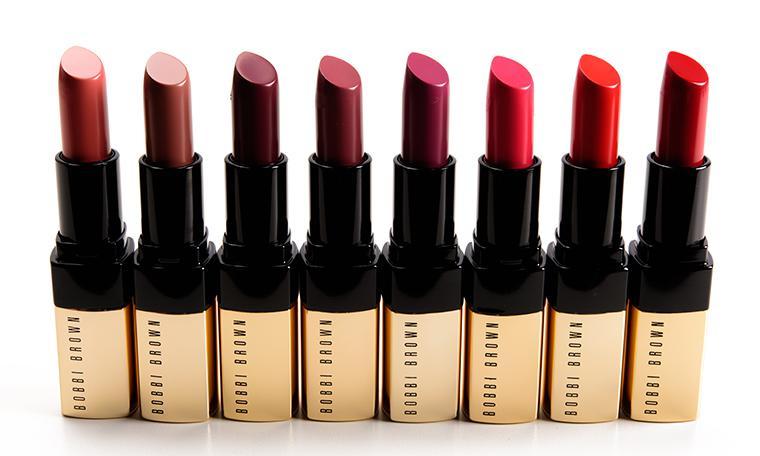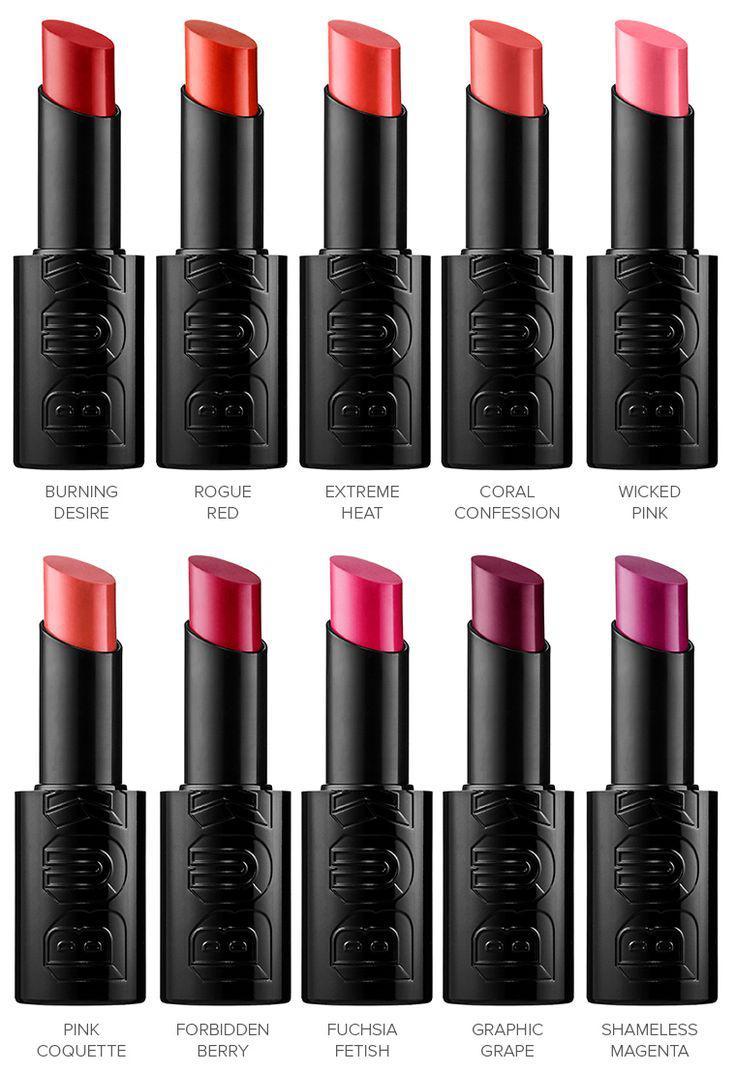The first image is the image on the left, the second image is the image on the right. For the images shown, is this caption "There are sixteen lipsticks in the right image." true? Answer yes or no. No. The first image is the image on the left, the second image is the image on the right. Examine the images to the left and right. Is the description "There are exactly four lipsticks in the right image." accurate? Answer yes or no. No. The first image is the image on the left, the second image is the image on the right. For the images shown, is this caption "The lipsticks are arranged in the shape of a diamond." true? Answer yes or no. No. 